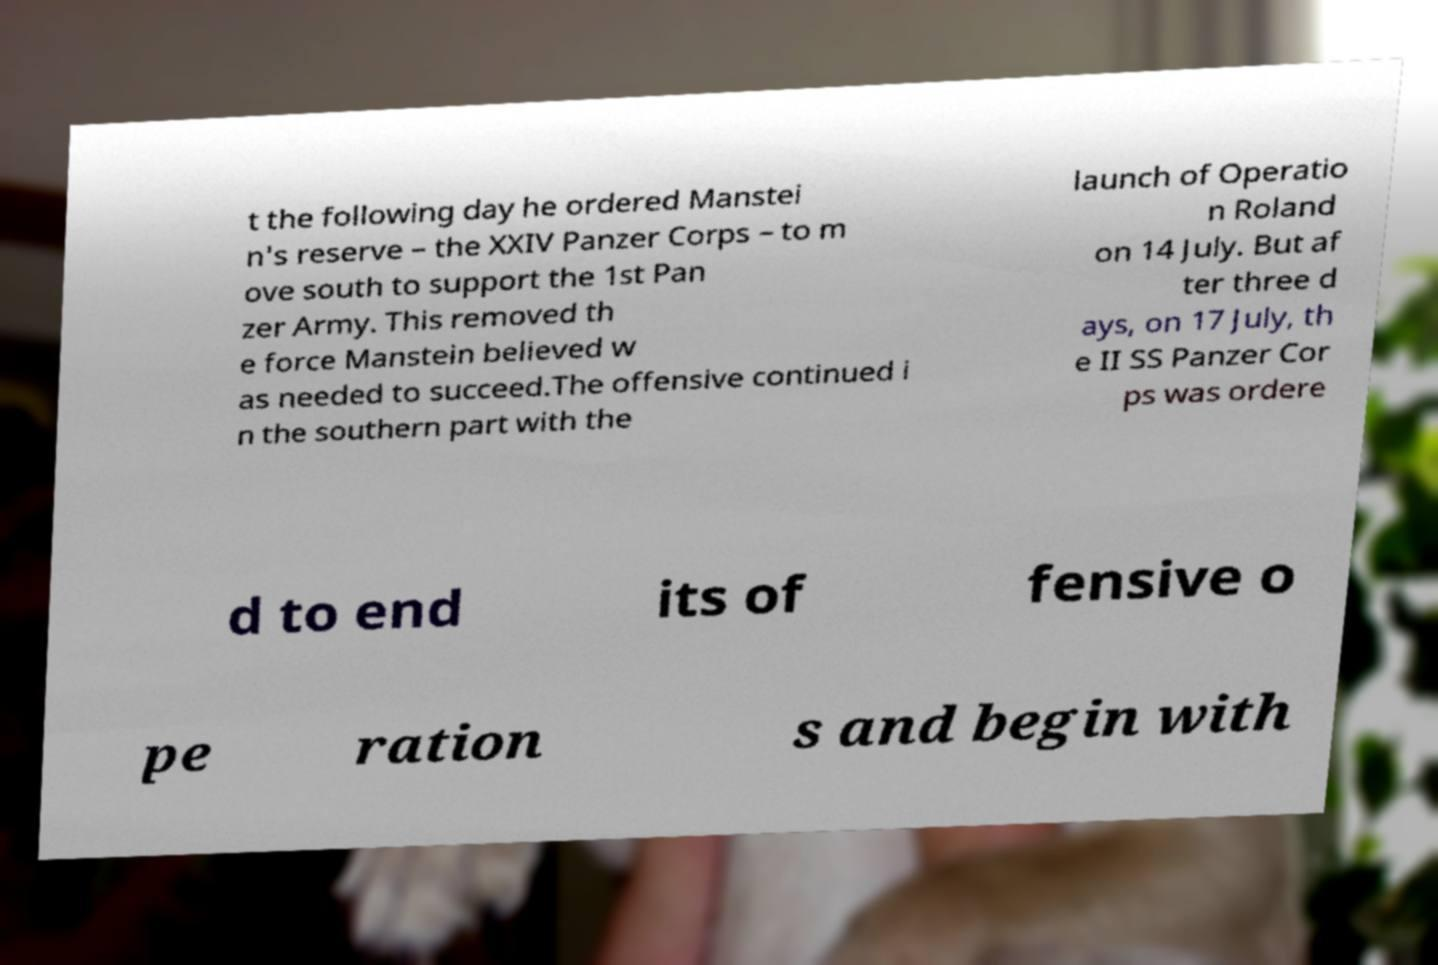There's text embedded in this image that I need extracted. Can you transcribe it verbatim? t the following day he ordered Manstei n's reserve – the XXIV Panzer Corps – to m ove south to support the 1st Pan zer Army. This removed th e force Manstein believed w as needed to succeed.The offensive continued i n the southern part with the launch of Operatio n Roland on 14 July. But af ter three d ays, on 17 July, th e II SS Panzer Cor ps was ordere d to end its of fensive o pe ration s and begin with 